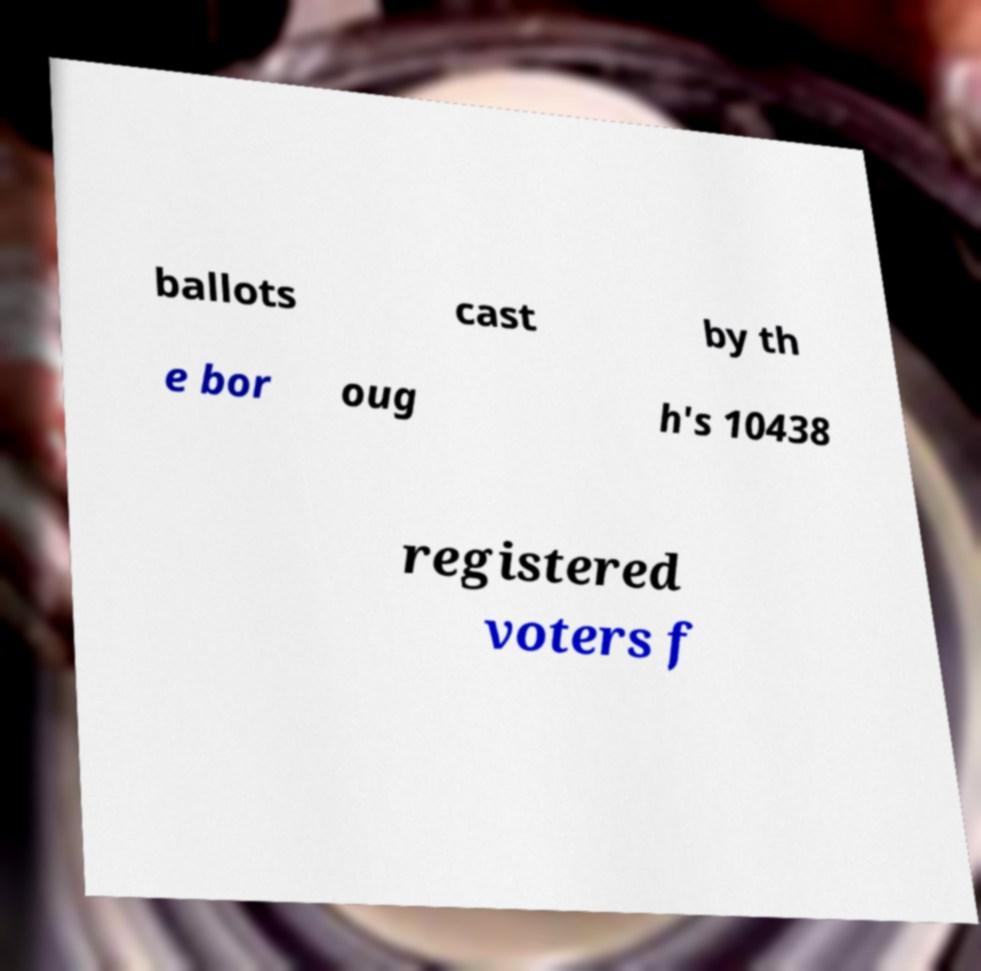Can you read and provide the text displayed in the image?This photo seems to have some interesting text. Can you extract and type it out for me? ballots cast by th e bor oug h's 10438 registered voters f 